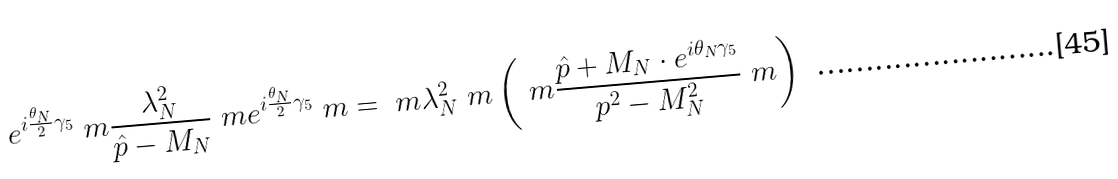<formula> <loc_0><loc_0><loc_500><loc_500>e ^ { i \frac { \theta _ { N } } { 2 } \gamma _ { 5 } } \ m \frac { \lambda _ { N } ^ { 2 } } { \hat { p } - M _ { N } } \ m e ^ { i \frac { \theta _ { N } } { 2 } \gamma _ { 5 } } \ m = \ m \lambda _ { N } ^ { 2 } \ m \left ( \ m \frac { \hat { p } + M _ { N } \cdot e ^ { i \theta _ { N } \gamma _ { 5 } } } { p ^ { 2 } - M _ { N } ^ { 2 } } \ m \right )</formula> 